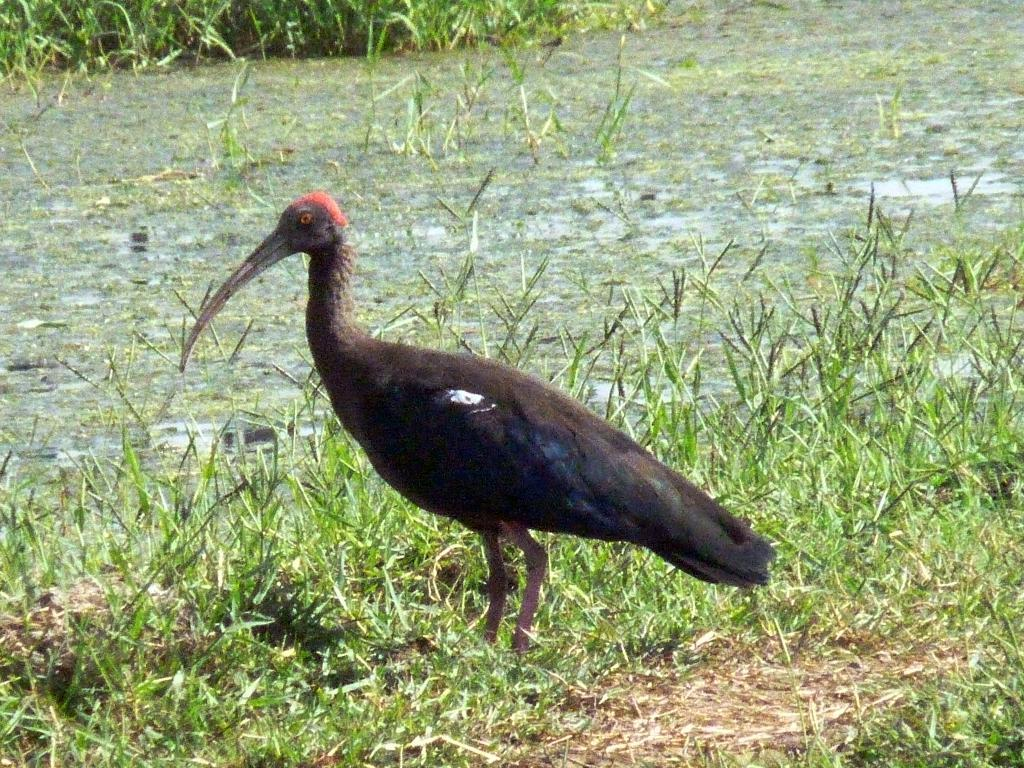What type of animal is in the image? There is a bird in the image. What colors can be seen on the bird? The bird has red, brown, blue, black, and white colors. Where is the bird located in the image? The bird is standing on the ground. What type of terrain is visible in the image? There is grass and water visible on the ground in the image. What type of punishment is being handed out in the image? There is no indication of punishment in the image; it features a bird standing on the ground near grass and water. What kind of building can be seen in the background of the image? There is no building present in the image; it is focused on the bird and the surrounding terrain. 